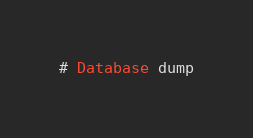<code> <loc_0><loc_0><loc_500><loc_500><_SQL_># Database dump
</code> 